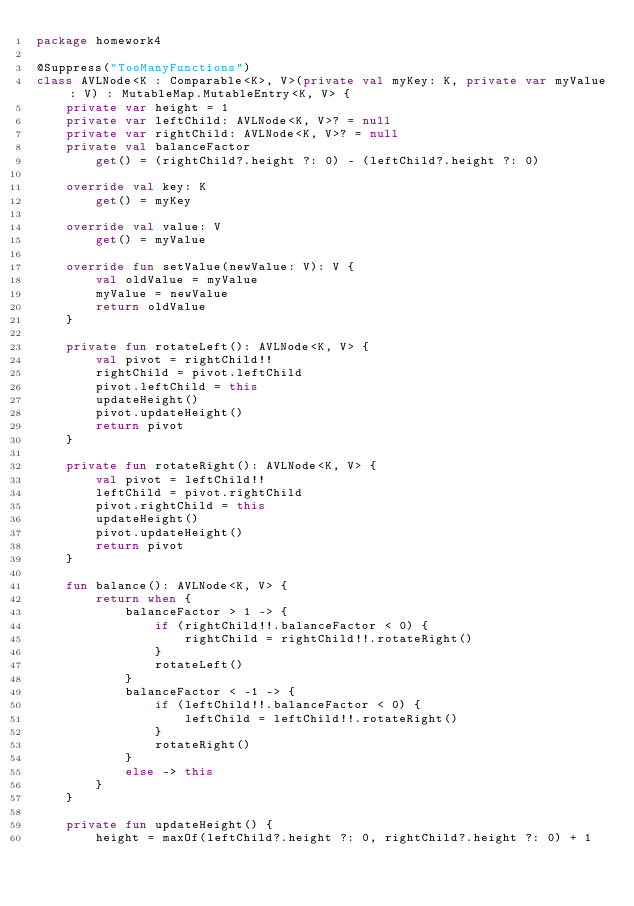Convert code to text. <code><loc_0><loc_0><loc_500><loc_500><_Kotlin_>package homework4

@Suppress("TooManyFunctions")
class AVLNode<K : Comparable<K>, V>(private val myKey: K, private var myValue: V) : MutableMap.MutableEntry<K, V> {
    private var height = 1
    private var leftChild: AVLNode<K, V>? = null
    private var rightChild: AVLNode<K, V>? = null
    private val balanceFactor
        get() = (rightChild?.height ?: 0) - (leftChild?.height ?: 0)

    override val key: K
        get() = myKey

    override val value: V
        get() = myValue

    override fun setValue(newValue: V): V {
        val oldValue = myValue
        myValue = newValue
        return oldValue
    }

    private fun rotateLeft(): AVLNode<K, V> {
        val pivot = rightChild!!
        rightChild = pivot.leftChild
        pivot.leftChild = this
        updateHeight()
        pivot.updateHeight()
        return pivot
    }

    private fun rotateRight(): AVLNode<K, V> {
        val pivot = leftChild!!
        leftChild = pivot.rightChild
        pivot.rightChild = this
        updateHeight()
        pivot.updateHeight()
        return pivot
    }

    fun balance(): AVLNode<K, V> {
        return when {
            balanceFactor > 1 -> {
                if (rightChild!!.balanceFactor < 0) {
                    rightChild = rightChild!!.rotateRight()
                }
                rotateLeft()
            }
            balanceFactor < -1 -> {
                if (leftChild!!.balanceFactor < 0) {
                    leftChild = leftChild!!.rotateRight()
                }
                rotateRight()
            }
            else -> this
        }
    }

    private fun updateHeight() {
        height = maxOf(leftChild?.height ?: 0, rightChild?.height ?: 0) + 1</code> 